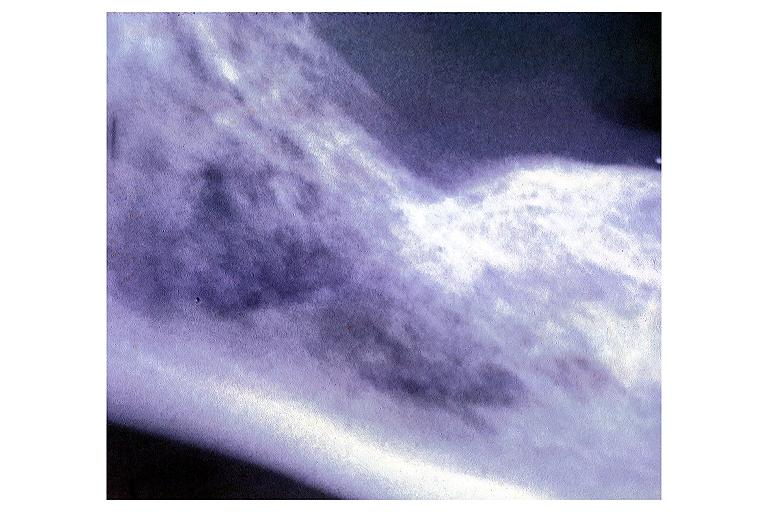s oral present?
Answer the question using a single word or phrase. Yes 